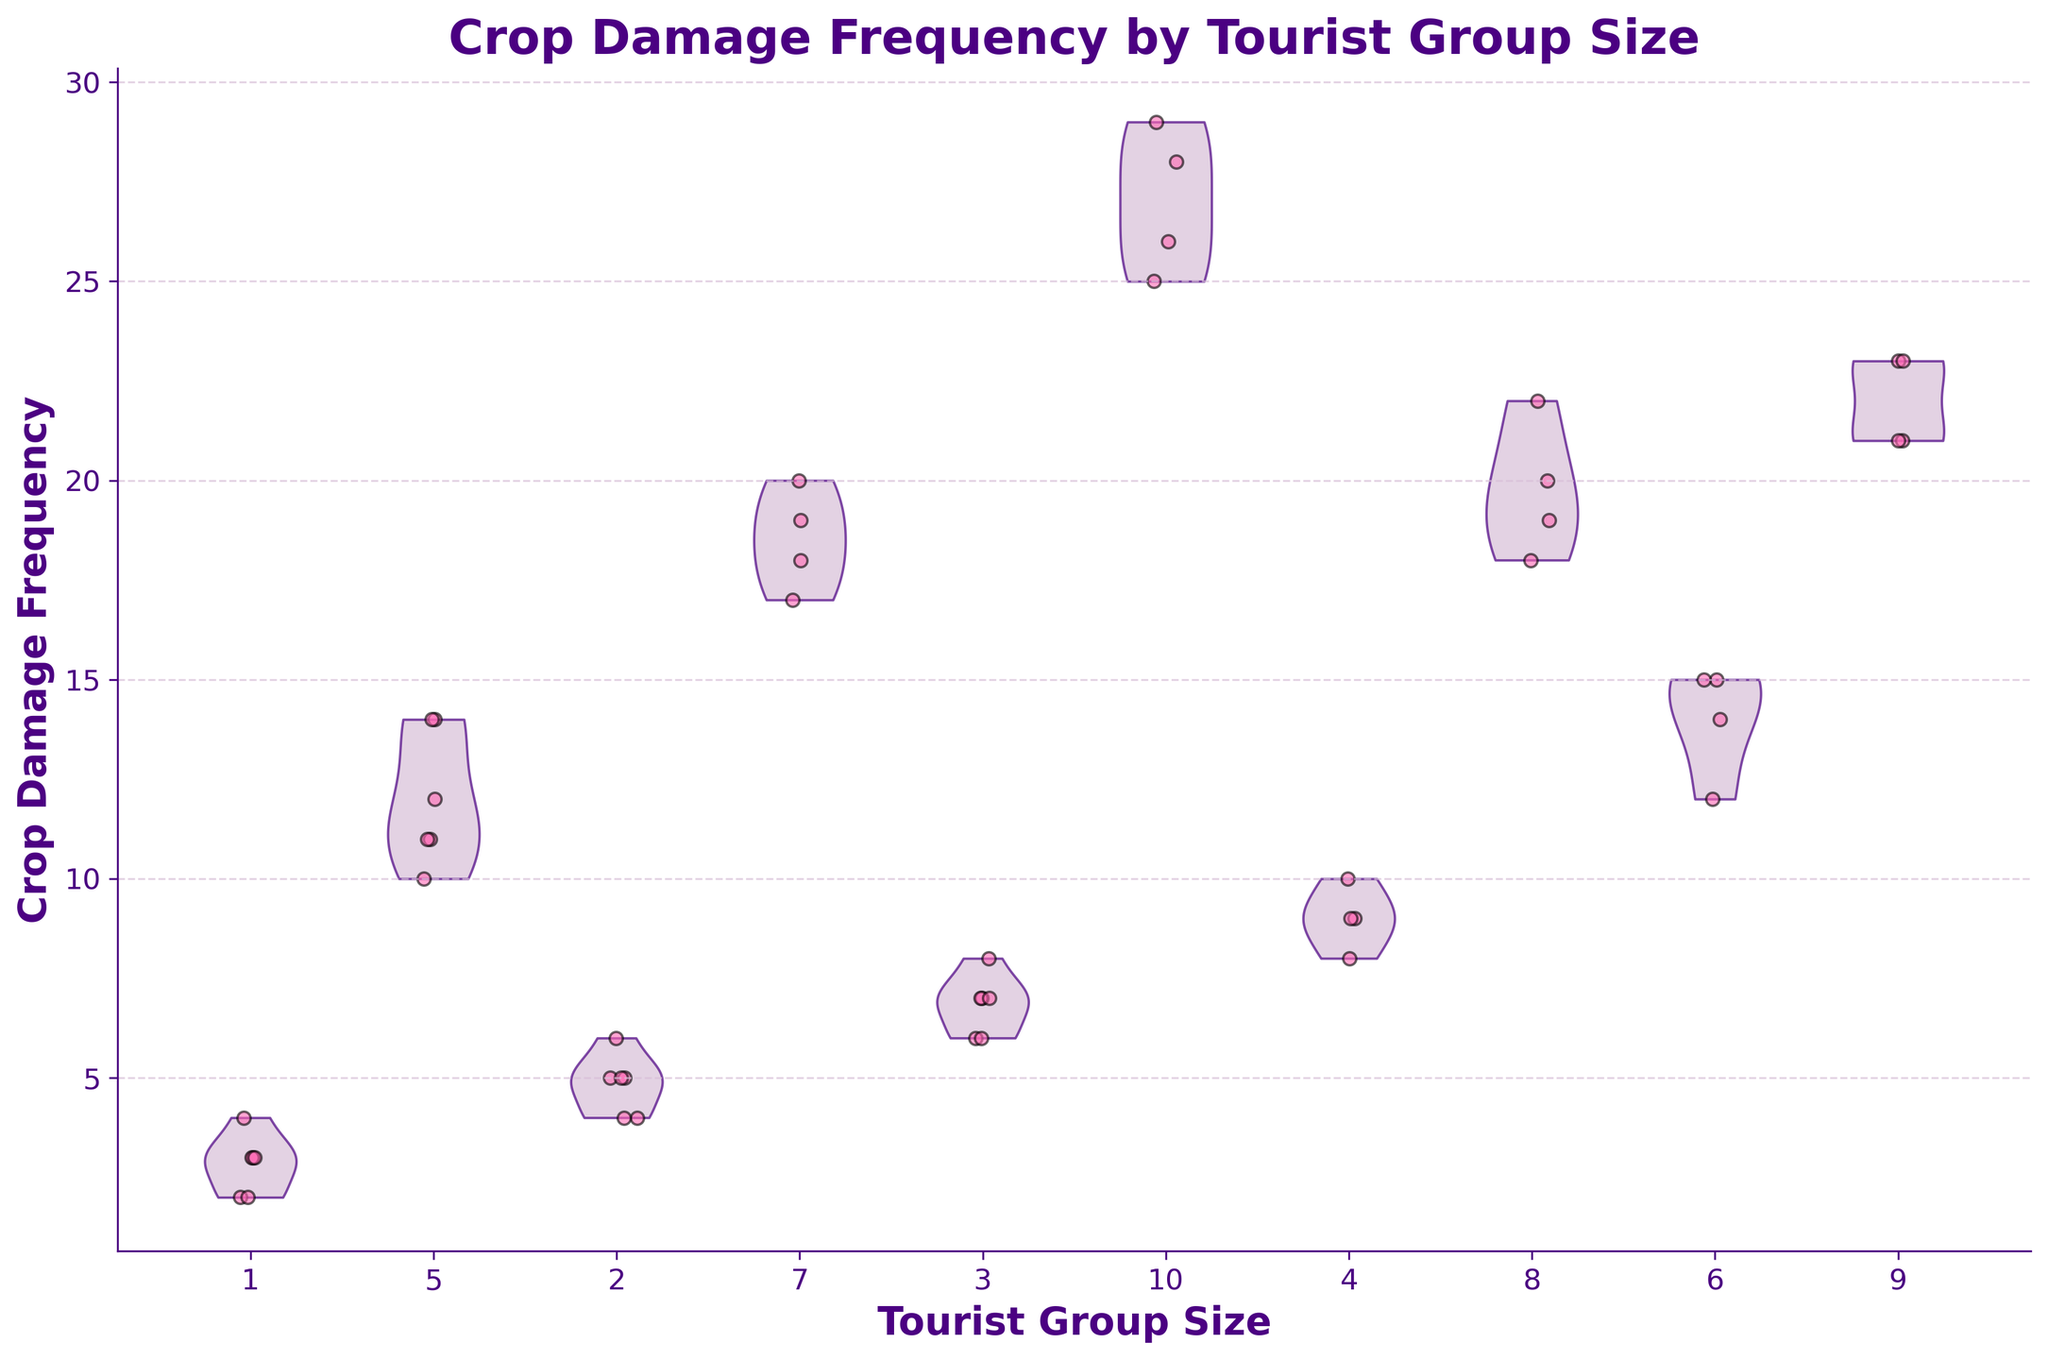what is the title of the figure? The title is located at the top of the figure in a large, bold font. It reads "Crop Damage Frequency by Tourist Group Size" which summarizes what the plot represents.
Answer: Crop Damage Frequency by Tourist Group Size what does the x-axis represent? The x-axis represents different tourist group sizes, indicated by numerical values (e.g., 1, 2, 3, etc.) shown along the axis.
Answer: Tourist group sizes what does the y-axis represent? The y-axis represents the crop damage frequency, indicated by numerical values that quantify the extent of crop damage per some time frame.
Answer: Crop damage frequency which tourist group size shows the highest crop damage frequency? Observing the violin plots and jittered points, it is clear that group sizes 10 have the widest spread and highest upper values, indicating higher crop damage frequencies.
Answer: 10 how do the points and the violins differ in color? The violins are colored in a pale lavender shade with an edge accent in indigo, while the points are shown in hot pink.
Answer: The violins are pale lavender with indigo edges and the points are hot pink how many tourist group sizes are represented in the figure? The x-axis ticks indicate a total, each representing a unique tourist group size. Counting these ticks, we find there are 10 group sizes represented.
Answer: 10 what's the range of crop damage frequency for group size 5? Examining the spread of the jittered points and the width of the violin plot for group size 5, crop damage frequency ranges from approximately 10 to 14.
Answer: 10 to 14 which tourist group size shows the least variation in crop damage frequency? By looking at the narrowest violin plot, we see that group size 1 exhibits the least variation in crop damage, as the plots are relatively narrow compared to others.
Answer: 1 compare the crop damage frequency of group sizes 2 and 8. which has higher values overall? Looking at the distribution widths and upper values, group size 8 consistently shows higher crop damage frequencies compared to group size 2.
Answer: Group size 8 